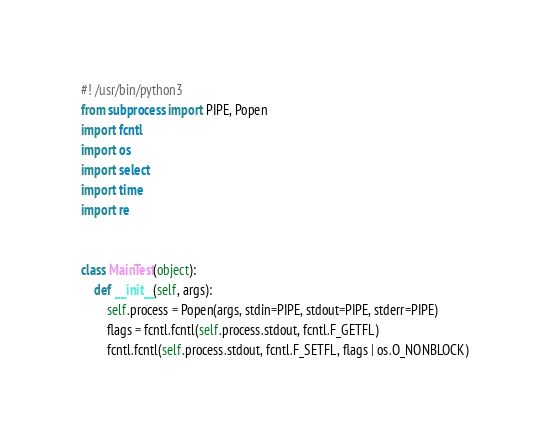<code> <loc_0><loc_0><loc_500><loc_500><_Python_>#! /usr/bin/python3
from subprocess import PIPE, Popen
import fcntl
import os
import select
import time
import re


class MainTest(object):
    def __init__(self, args):
        self.process = Popen(args, stdin=PIPE, stdout=PIPE, stderr=PIPE)
        flags = fcntl.fcntl(self.process.stdout, fcntl.F_GETFL)
        fcntl.fcntl(self.process.stdout, fcntl.F_SETFL, flags | os.O_NONBLOCK)
</code> 